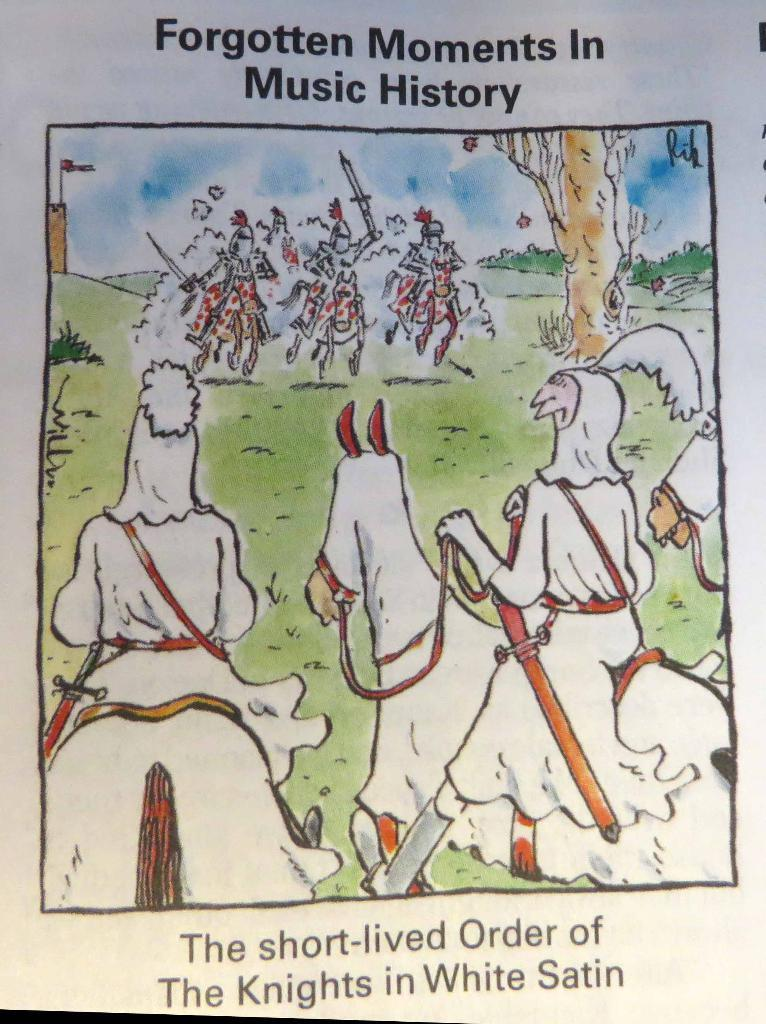What is depicted on the paper in the image? The paper contains an image of grass and horses. What are the horses doing in the image? There are people sitting on the horses in the image. Is there any text on the paper? Yes, there is writing on the paper. What type of patch can be seen on the horses in the image? There is no mention of a patch on the horses in the image; the facts only mention that there are people sitting on the horses. How much honey is visible on the paper in the image? There is no honey present in the image; the facts only mention the images of grass and horses, writing on the paper, and people sitting on the horses. 